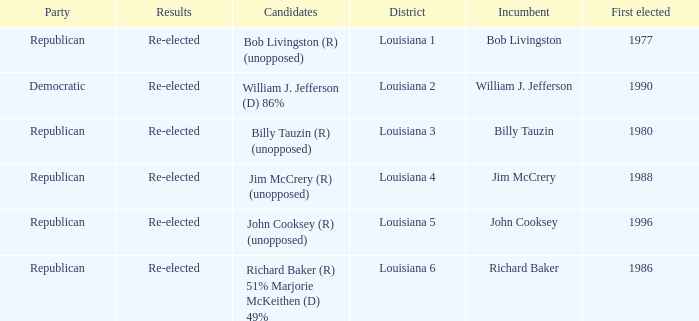How many contenders were elected first in 1980? 1.0. 